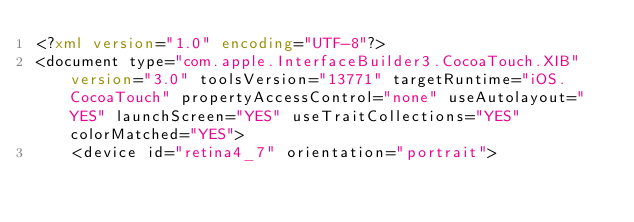<code> <loc_0><loc_0><loc_500><loc_500><_XML_><?xml version="1.0" encoding="UTF-8"?>
<document type="com.apple.InterfaceBuilder3.CocoaTouch.XIB" version="3.0" toolsVersion="13771" targetRuntime="iOS.CocoaTouch" propertyAccessControl="none" useAutolayout="YES" launchScreen="YES" useTraitCollections="YES" colorMatched="YES">
    <device id="retina4_7" orientation="portrait"></code> 